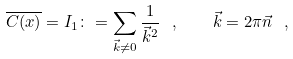Convert formula to latex. <formula><loc_0><loc_0><loc_500><loc_500>\overline { C ( x ) } = I _ { 1 } \colon = \sum _ { \vec { k } \not = 0 } \frac { 1 } { { \vec { k } } ^ { 2 } } \ , \quad \vec { k } = { 2 \pi } \vec { n } \ ,</formula> 